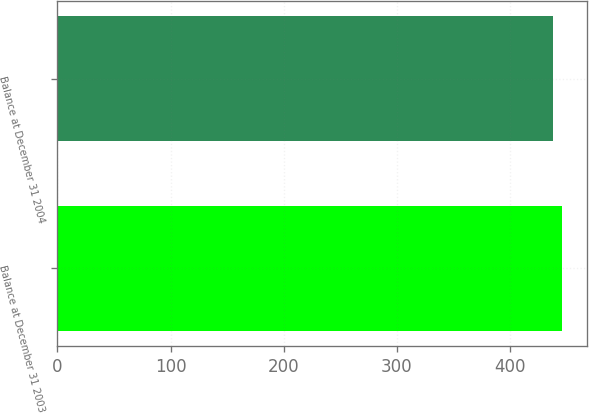Convert chart to OTSL. <chart><loc_0><loc_0><loc_500><loc_500><bar_chart><fcel>Balance at December 31 2003<fcel>Balance at December 31 2004<nl><fcel>446<fcel>438<nl></chart> 